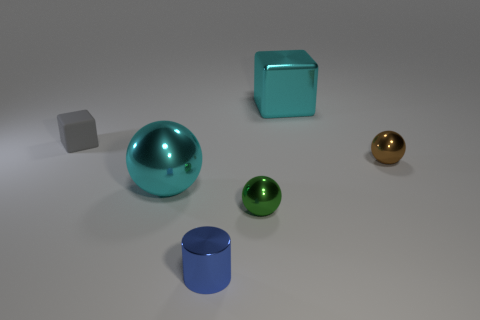Is the number of small shiny spheres on the left side of the blue metal cylinder less than the number of spheres in front of the tiny green object?
Your response must be concise. No. There is a shiny ball that is behind the cyan metallic ball; what color is it?
Make the answer very short. Brown. What number of other objects are there of the same color as the tiny rubber object?
Offer a terse response. 0. There is a cyan thing on the right side of the green thing; does it have the same size as the tiny blue shiny thing?
Offer a terse response. No. How many small metal spheres are left of the small gray thing?
Keep it short and to the point. 0. Is there a gray rubber object of the same size as the green metal object?
Keep it short and to the point. Yes. Is the small metal cylinder the same color as the rubber block?
Keep it short and to the point. No. The tiny sphere on the right side of the cube behind the small rubber cube is what color?
Your response must be concise. Brown. What number of tiny shiny objects are in front of the green sphere and behind the small blue object?
Make the answer very short. 0. What number of green objects are the same shape as the brown thing?
Offer a very short reply. 1. 